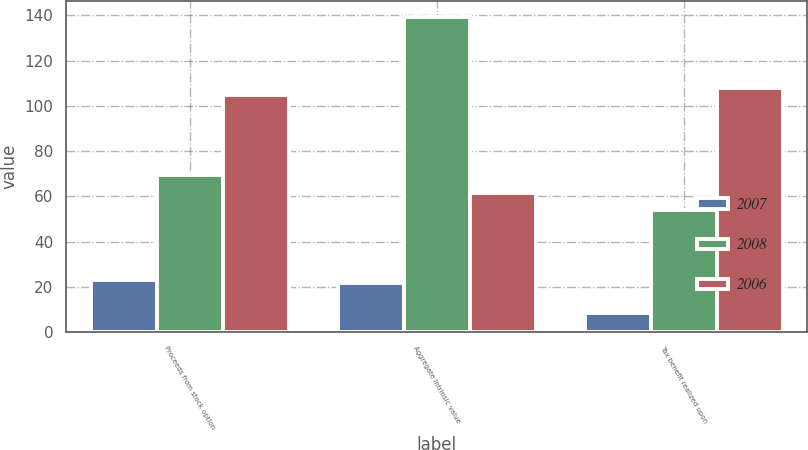<chart> <loc_0><loc_0><loc_500><loc_500><stacked_bar_chart><ecel><fcel>Proceeds from stock option<fcel>Aggregate intrinsic value<fcel>Tax benefit realized upon<nl><fcel>2007<fcel>23.2<fcel>21.6<fcel>8.5<nl><fcel>2008<fcel>69.3<fcel>139.4<fcel>53.9<nl><fcel>2006<fcel>105<fcel>61.6<fcel>108<nl></chart> 